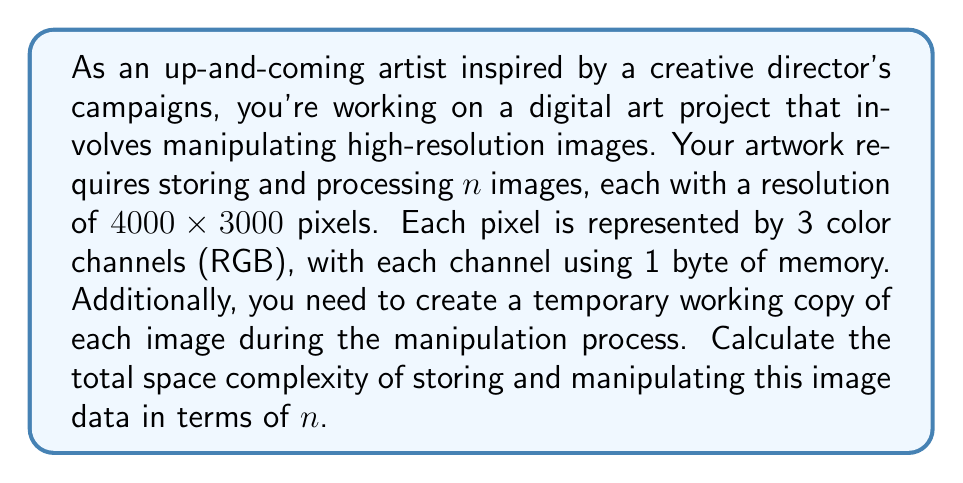Give your solution to this math problem. Let's break down the problem step by step:

1) First, calculate the size of a single image:
   - Resolution: $4000 \times 3000 = 12,000,000$ pixels
   - Each pixel has 3 color channels (RGB)
   - Each channel uses 1 byte
   
   So, the size of one image is:
   $$ 12,000,000 \times 3 \times 1 = 36,000,000 \text{ bytes} = 36 \text{ MB} $$

2) We need to store $n$ images, so the space required for storing the original images is:
   $$ 36n \text{ MB} $$

3) For manipulation, we need a temporary working copy of each image. This doubles the space requirement:
   $$ 36n \text{ MB} \times 2 = 72n \text{ MB} $$

4) Convert MB to bytes:
   $$ 72n \text{ MB} = 72n \times 1,000,000 \text{ bytes} = 72,000,000n \text{ bytes} $$

5) In Big O notation, we ignore constant factors. Therefore, the space complexity is:
   $$ O(n) $$

The space complexity is linear in terms of $n$, the number of images.
Answer: $O(n)$ 